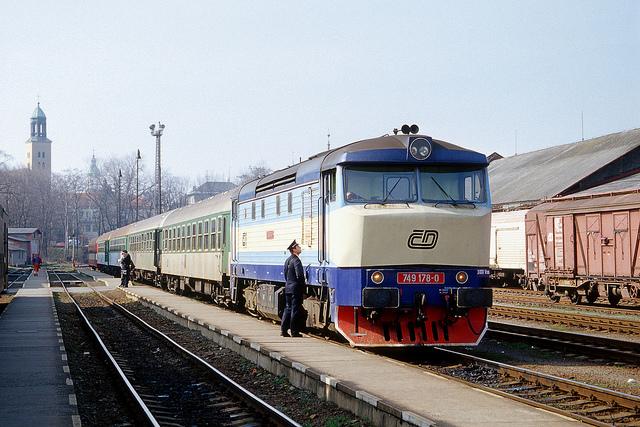Is the train moving?
Concise answer only. No. Are there any people in this scene?
Answer briefly. Yes. Is this train hauling cargo or people?
Keep it brief. People. What is the job of the man standing?
Write a very short answer. Conductor. 